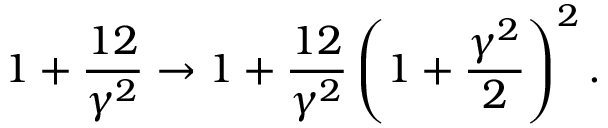<formula> <loc_0><loc_0><loc_500><loc_500>1 + \frac { 1 2 } { \gamma ^ { 2 } } \to 1 + \frac { 1 2 } { \gamma ^ { 2 } } \left ( 1 + \frac { \gamma ^ { 2 } } { 2 } \right ) ^ { 2 } .</formula> 